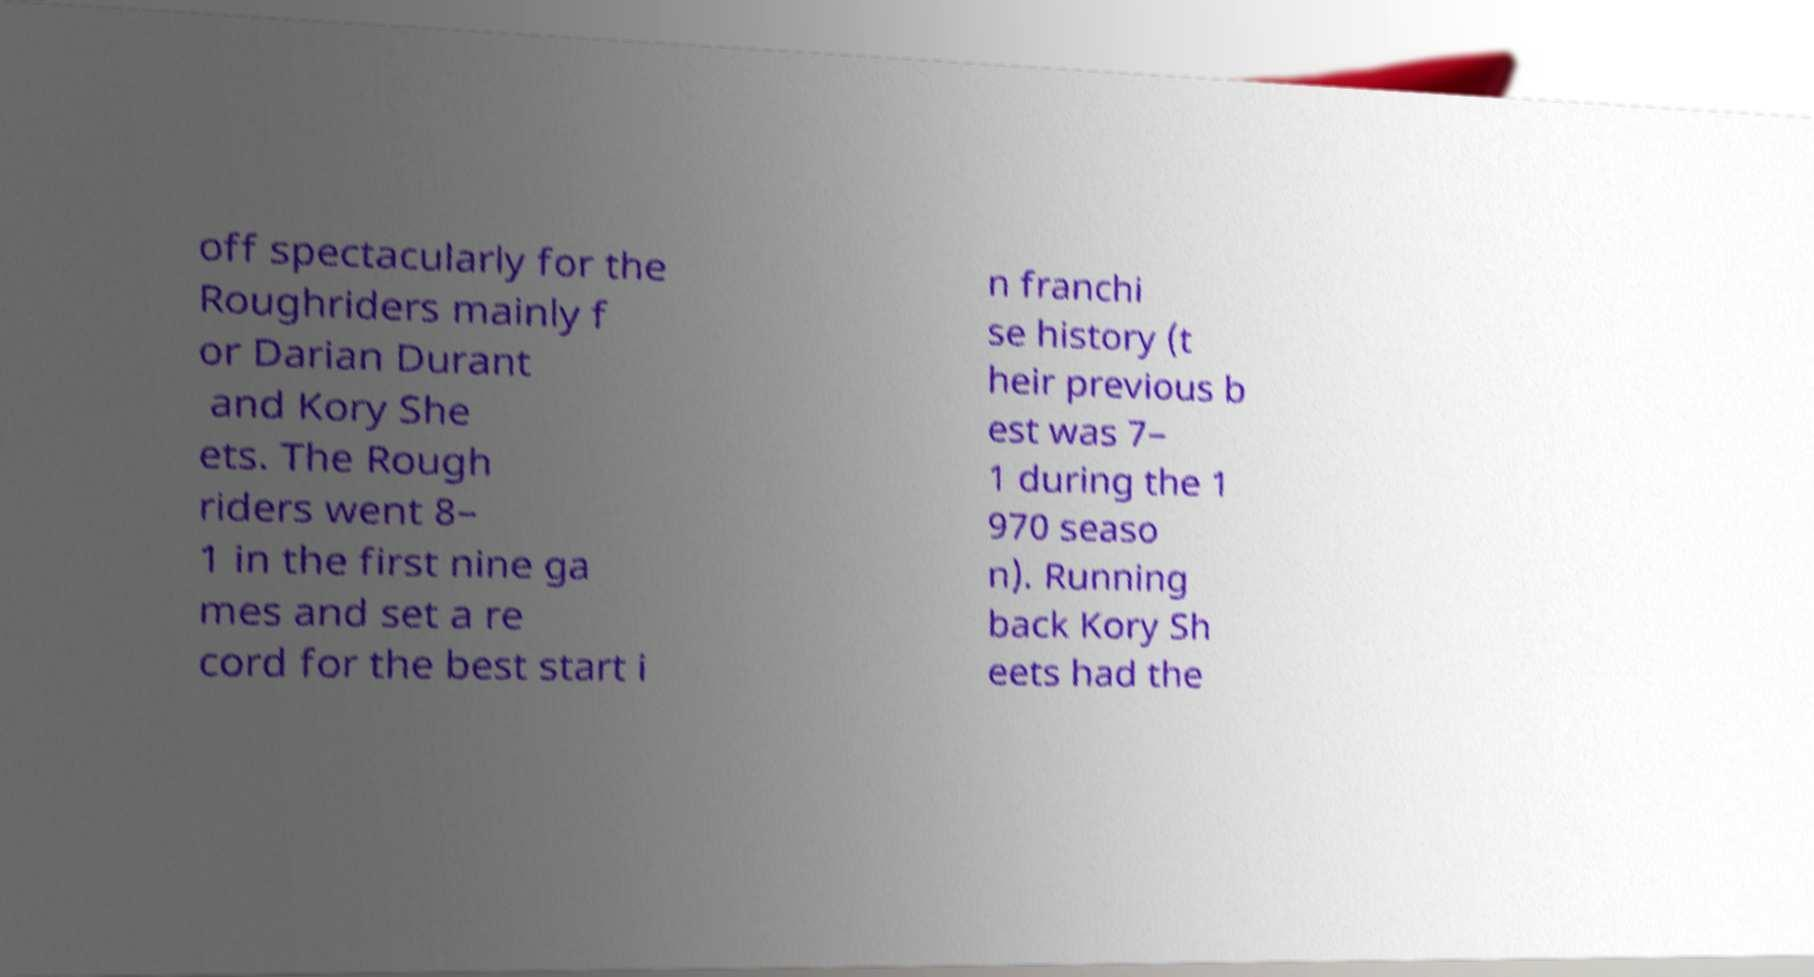For documentation purposes, I need the text within this image transcribed. Could you provide that? off spectacularly for the Roughriders mainly f or Darian Durant and Kory She ets. The Rough riders went 8– 1 in the first nine ga mes and set a re cord for the best start i n franchi se history (t heir previous b est was 7– 1 during the 1 970 seaso n). Running back Kory Sh eets had the 